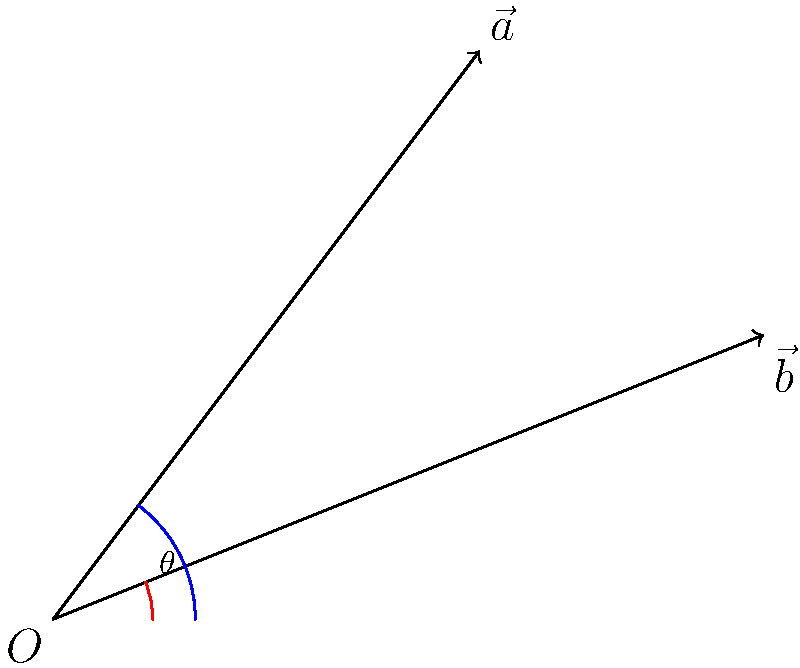During a crucial match of Sheikh Russel Kurmitola Club, a player attempts two consecutive kicks. The first kick's trajectory is represented by vector $\vec{a} = 3\hat{i} + 4\hat{j}$, while the second kick's trajectory is represented by vector $\vec{b} = 5\hat{i} + 2\hat{j}$. Calculate the angle $\theta$ between these two vectors. To find the angle between two vectors, we can use the dot product formula:

$$\cos \theta = \frac{\vec{a} \cdot \vec{b}}{|\vec{a}||\vec{b}|}$$

Step 1: Calculate the dot product $\vec{a} \cdot \vec{b}$
$$\vec{a} \cdot \vec{b} = (3)(5) + (4)(2) = 15 + 8 = 23$$

Step 2: Calculate the magnitudes of $\vec{a}$ and $\vec{b}$
$$|\vec{a}| = \sqrt{3^2 + 4^2} = \sqrt{9 + 16} = \sqrt{25} = 5$$
$$|\vec{b}| = \sqrt{5^2 + 2^2} = \sqrt{25 + 4} = \sqrt{29}$$

Step 3: Substitute into the dot product formula
$$\cos \theta = \frac{23}{5\sqrt{29}}$$

Step 4: Take the inverse cosine (arccos) of both sides
$$\theta = \arccos(\frac{23}{5\sqrt{29}})$$

Step 5: Calculate the result (using a calculator)
$$\theta \approx 0.3398 \text{ radians}$$

Step 6: Convert to degrees
$$\theta \approx 0.3398 \times \frac{180°}{\pi} \approx 19.47°$$
Answer: $19.47°$ 